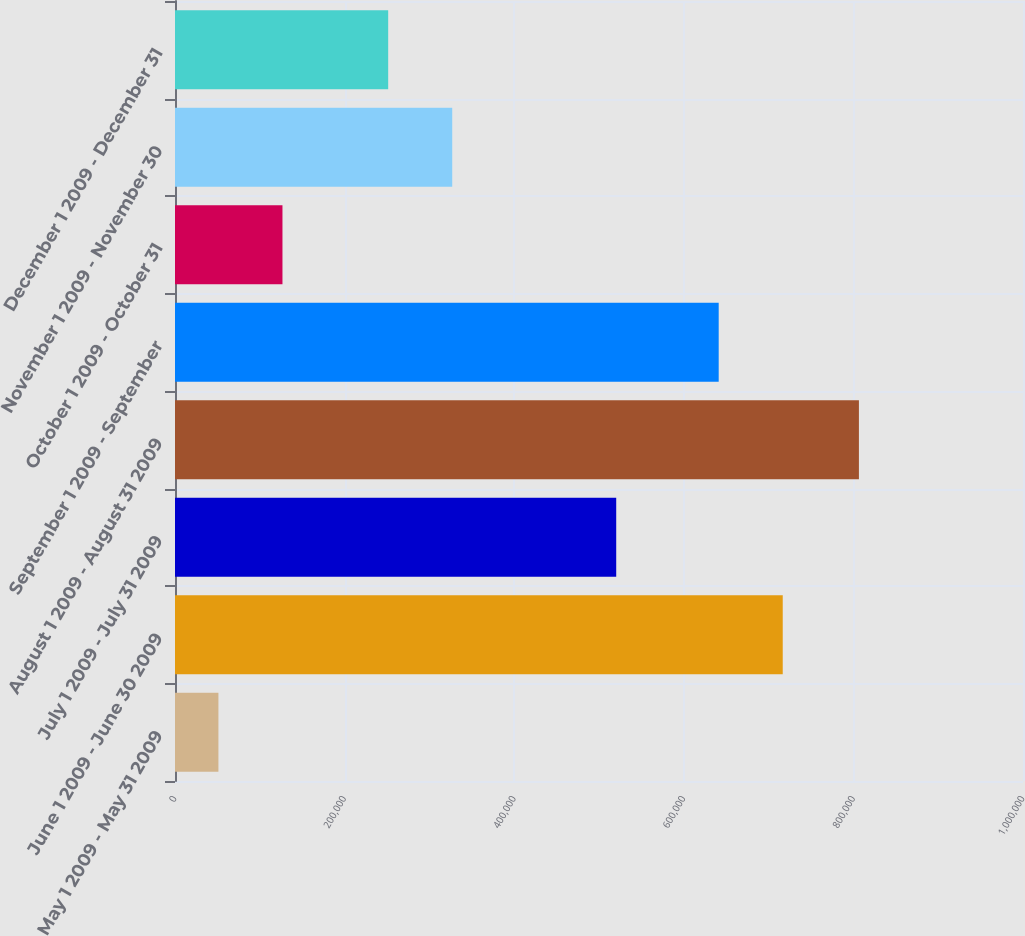Convert chart to OTSL. <chart><loc_0><loc_0><loc_500><loc_500><bar_chart><fcel>May 1 2009 - May 31 2009<fcel>June 1 2009 - June 30 2009<fcel>July 1 2009 - July 31 2009<fcel>August 1 2009 - August 31 2009<fcel>September 1 2009 - September<fcel>October 1 2009 - October 31<fcel>November 1 2009 - November 30<fcel>December 1 2009 - December 31<nl><fcel>51200<fcel>716676<fcel>520300<fcel>806500<fcel>641146<fcel>126730<fcel>326930<fcel>251400<nl></chart> 